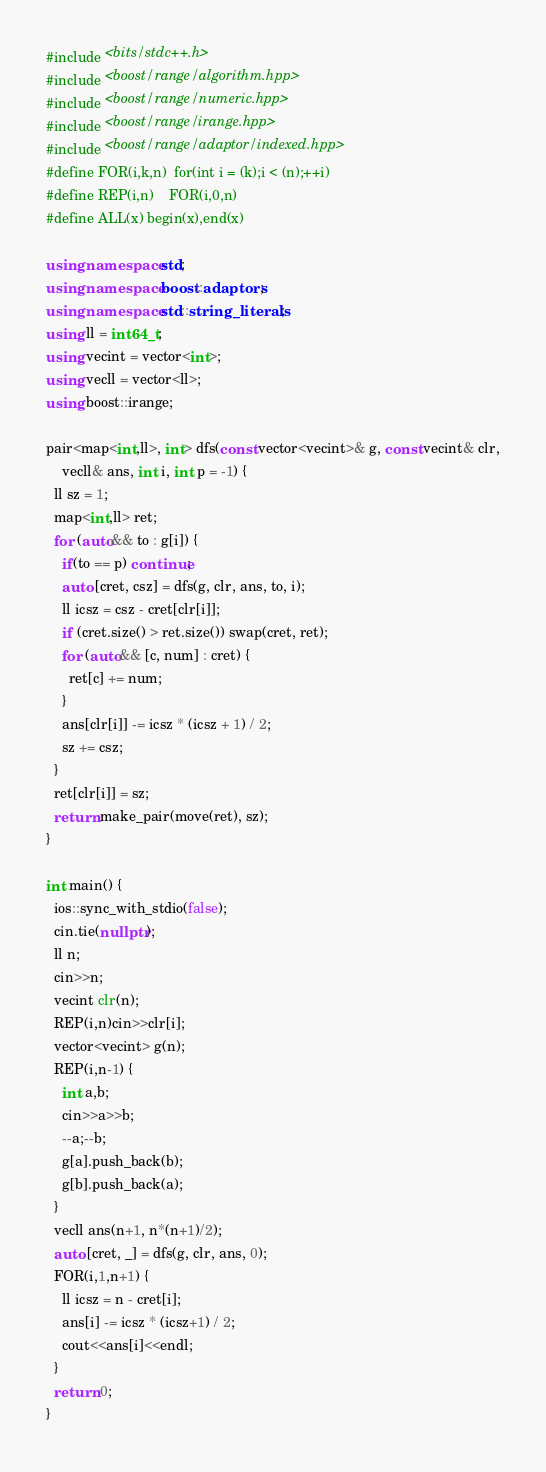Convert code to text. <code><loc_0><loc_0><loc_500><loc_500><_C++_>#include <bits/stdc++.h>
#include <boost/range/algorithm.hpp>
#include <boost/range/numeric.hpp>
#include <boost/range/irange.hpp>
#include <boost/range/adaptor/indexed.hpp>
#define FOR(i,k,n)  for(int i = (k);i < (n);++i)
#define REP(i,n)    FOR(i,0,n)
#define ALL(x) begin(x),end(x)

using namespace std;
using namespace boost::adaptors;
using namespace std::string_literals;
using ll = int64_t;
using vecint = vector<int>;
using vecll = vector<ll>;
using boost::irange;

pair<map<int,ll>, int> dfs(const vector<vecint>& g, const vecint& clr,
    vecll& ans, int i, int p = -1) {
  ll sz = 1;
  map<int,ll> ret;
  for (auto&& to : g[i]) {
    if(to == p) continue;
    auto [cret, csz] = dfs(g, clr, ans, to, i);
    ll icsz = csz - cret[clr[i]];
    if (cret.size() > ret.size()) swap(cret, ret);
    for (auto&& [c, num] : cret) {
      ret[c] += num;
    }
    ans[clr[i]] -= icsz * (icsz + 1) / 2;
    sz += csz;
  }
  ret[clr[i]] = sz;
  return make_pair(move(ret), sz);
}

int main() {
  ios::sync_with_stdio(false);
  cin.tie(nullptr);
  ll n;
  cin>>n;
  vecint clr(n);
  REP(i,n)cin>>clr[i];
  vector<vecint> g(n);
  REP(i,n-1) {
    int a,b;
    cin>>a>>b;
    --a;--b;
    g[a].push_back(b);
    g[b].push_back(a);
  }
  vecll ans(n+1, n*(n+1)/2);
  auto [cret, _] = dfs(g, clr, ans, 0);
  FOR(i,1,n+1) {
    ll icsz = n - cret[i];
    ans[i] -= icsz * (icsz+1) / 2;
    cout<<ans[i]<<endl;
  }
  return 0;
}
</code> 